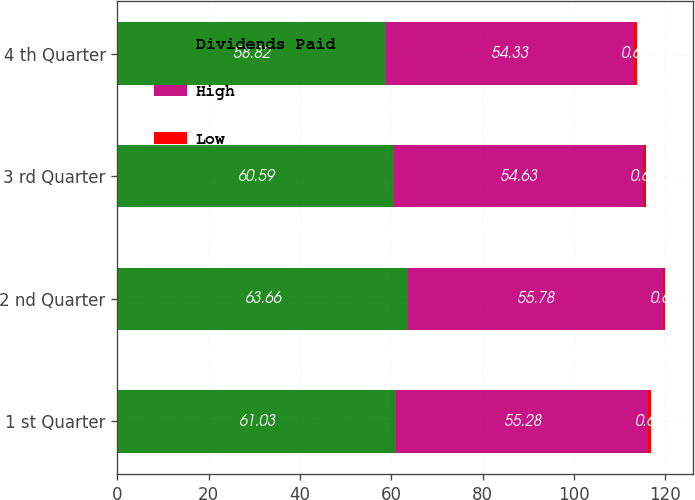<chart> <loc_0><loc_0><loc_500><loc_500><stacked_bar_chart><ecel><fcel>1 st Quarter<fcel>2 nd Quarter<fcel>3 rd Quarter<fcel>4 th Quarter<nl><fcel>Dividends Paid<fcel>61.03<fcel>63.66<fcel>60.59<fcel>58.82<nl><fcel>High<fcel>55.28<fcel>55.78<fcel>54.63<fcel>54.33<nl><fcel>Low<fcel>0.61<fcel>0.61<fcel>0.61<fcel>0.61<nl></chart> 